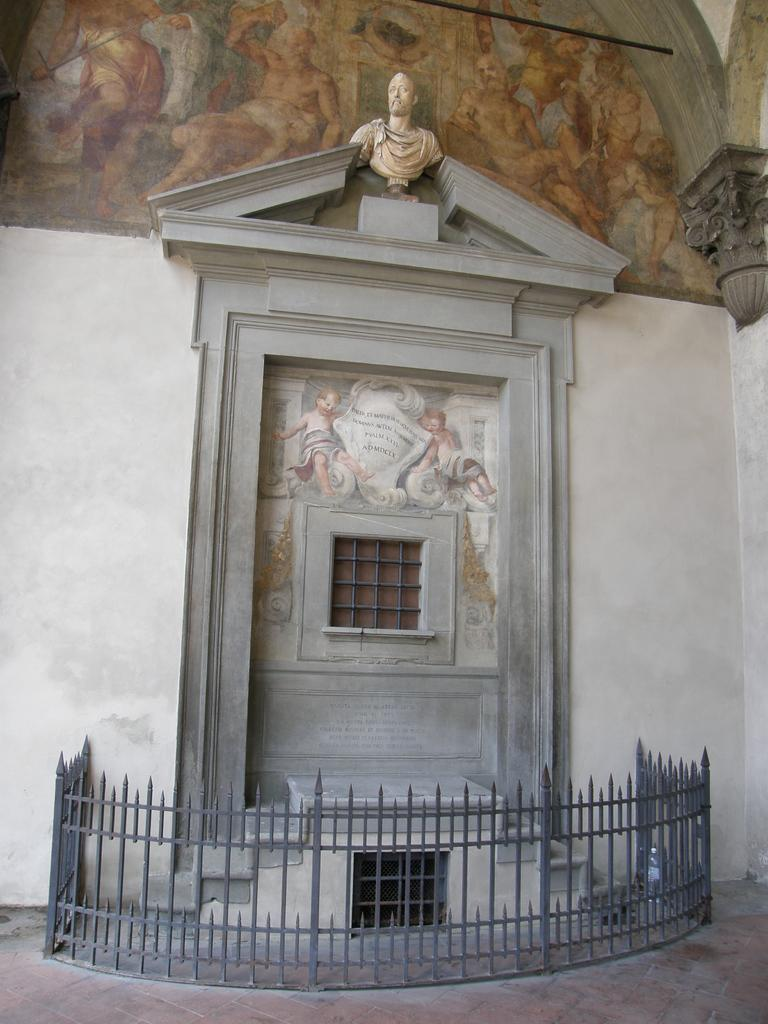What is the main subject in the image? There is a statue in the image. What other structures or objects can be seen in the image? There is a building, a window, and a grill visible in the image. Are there any decorations or artwork in the image? Yes, there are paintings on the walls in the image. How many geese are flying over the statue in the image? There are no geese present in the image; it only features a statue, a building, a window, paintings on the walls, and a grill. 